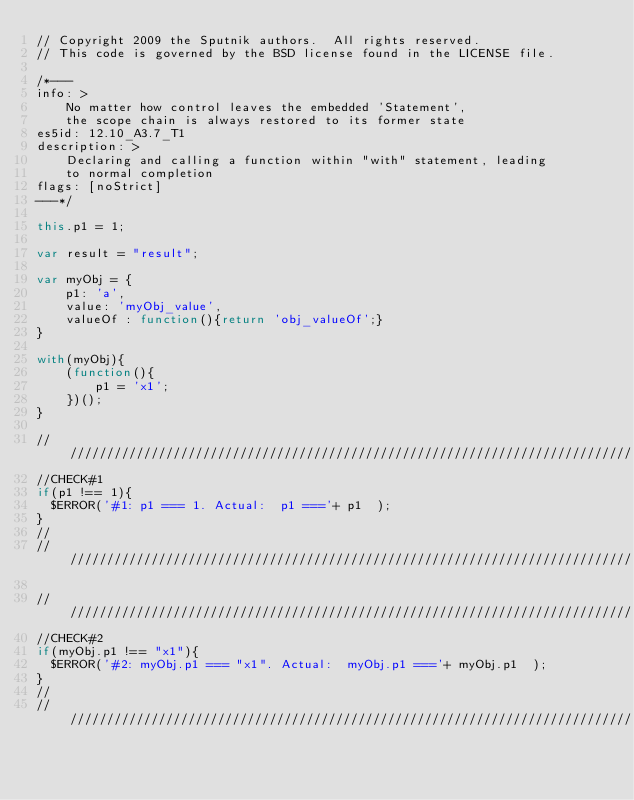Convert code to text. <code><loc_0><loc_0><loc_500><loc_500><_JavaScript_>// Copyright 2009 the Sputnik authors.  All rights reserved.
// This code is governed by the BSD license found in the LICENSE file.

/*---
info: >
    No matter how control leaves the embedded 'Statement',
    the scope chain is always restored to its former state
es5id: 12.10_A3.7_T1
description: >
    Declaring and calling a function within "with" statement, leading
    to normal completion
flags: [noStrict]
---*/

this.p1 = 1;

var result = "result";

var myObj = {
    p1: 'a', 
    value: 'myObj_value',
    valueOf : function(){return 'obj_valueOf';}
}

with(myObj){
    (function(){
        p1 = 'x1';
    })();
}

//////////////////////////////////////////////////////////////////////////////
//CHECK#1
if(p1 !== 1){
  $ERROR('#1: p1 === 1. Actual:  p1 ==='+ p1  );
}
//
//////////////////////////////////////////////////////////////////////////////

//////////////////////////////////////////////////////////////////////////////
//CHECK#2
if(myObj.p1 !== "x1"){
  $ERROR('#2: myObj.p1 === "x1". Actual:  myObj.p1 ==='+ myObj.p1  );
}
//
//////////////////////////////////////////////////////////////////////////////
</code> 